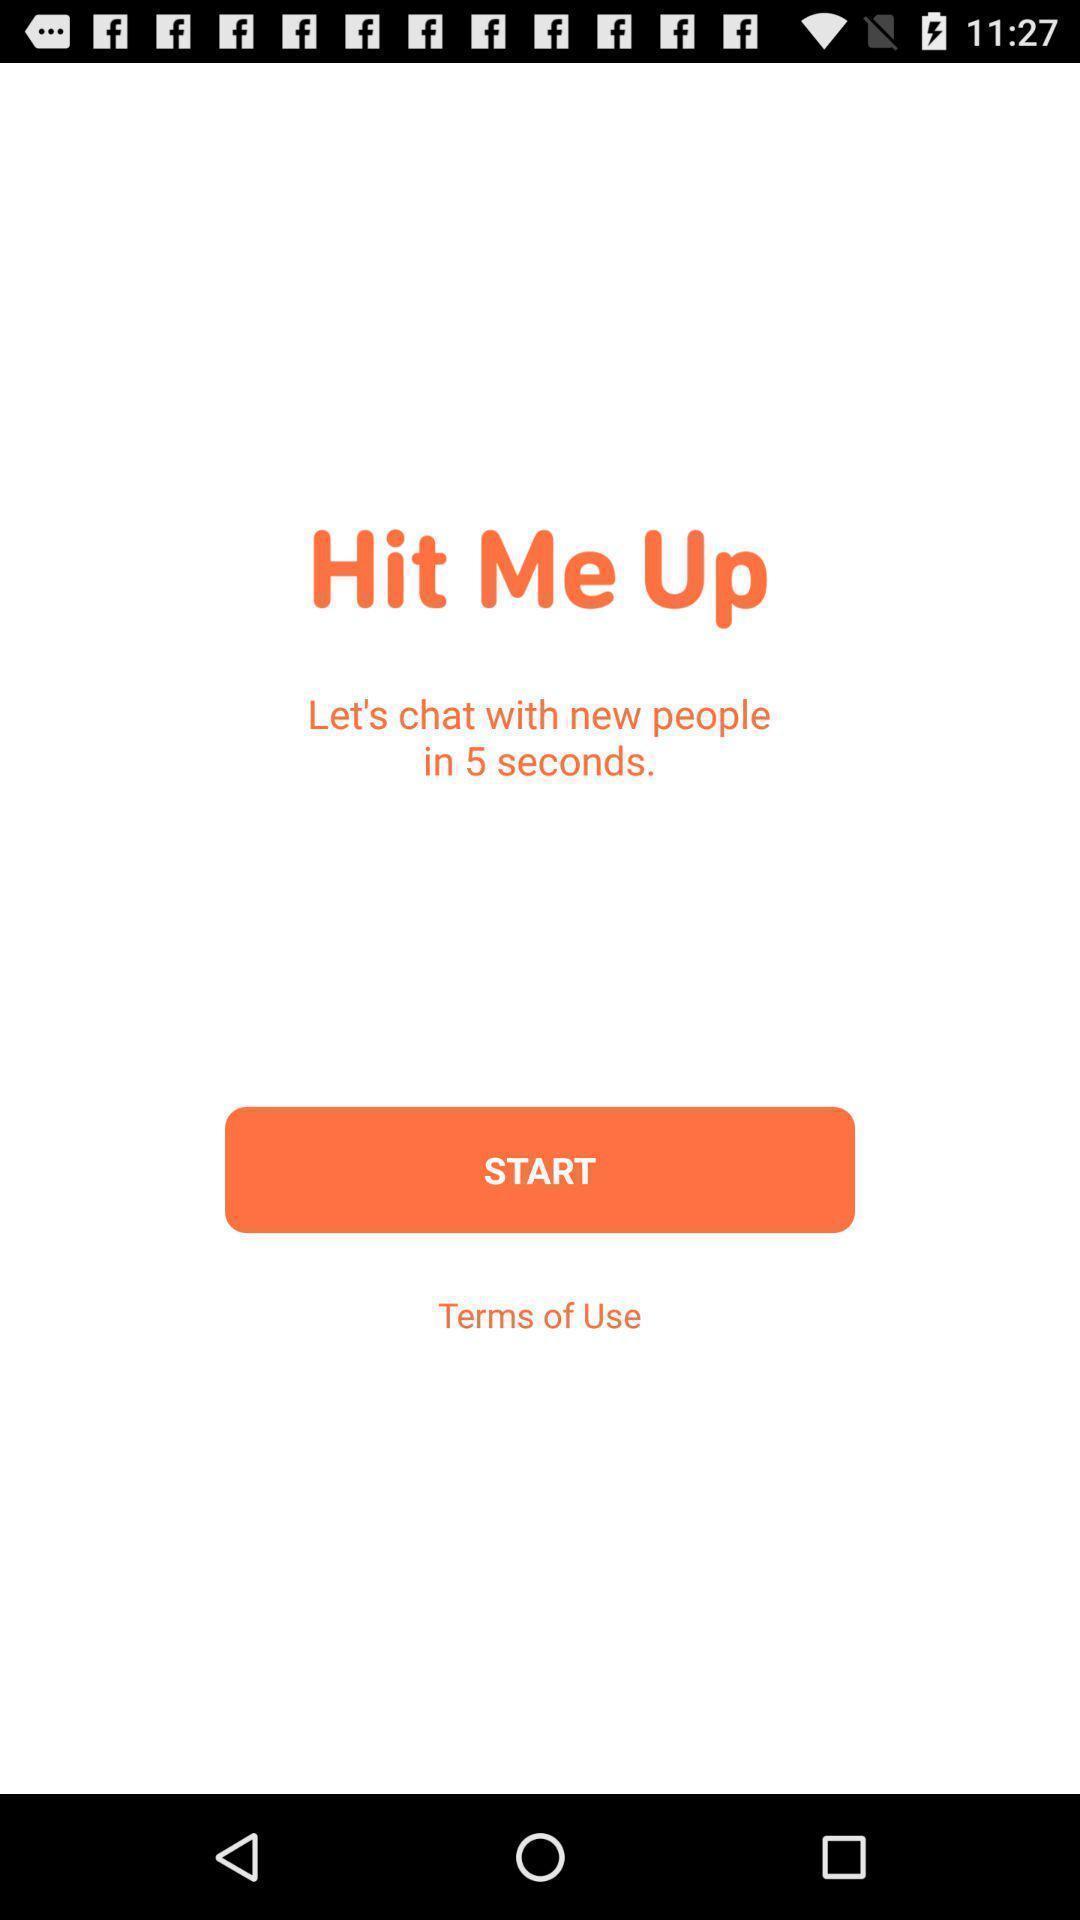Explain what's happening in this screen capture. Welcome page with start option. 